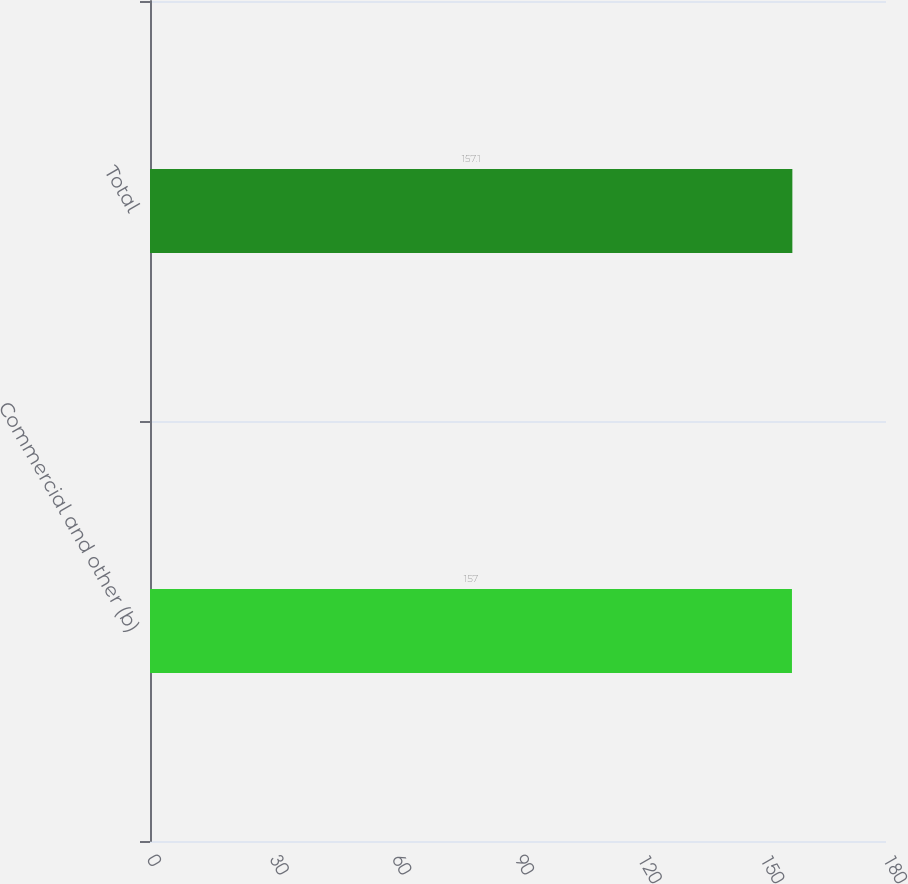<chart> <loc_0><loc_0><loc_500><loc_500><bar_chart><fcel>Commercial and other (b)<fcel>Total<nl><fcel>157<fcel>157.1<nl></chart> 